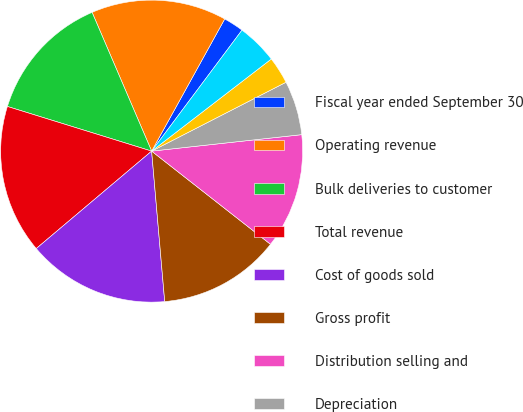Convert chart. <chart><loc_0><loc_0><loc_500><loc_500><pie_chart><fcel>Fiscal year ended September 30<fcel>Operating revenue<fcel>Bulk deliveries to customer<fcel>Total revenue<fcel>Cost of goods sold<fcel>Gross profit<fcel>Distribution selling and<fcel>Depreciation<fcel>Amortization<fcel>Facility consolidations<nl><fcel>2.17%<fcel>14.49%<fcel>13.77%<fcel>15.94%<fcel>15.22%<fcel>13.04%<fcel>12.32%<fcel>5.8%<fcel>2.9%<fcel>4.35%<nl></chart> 